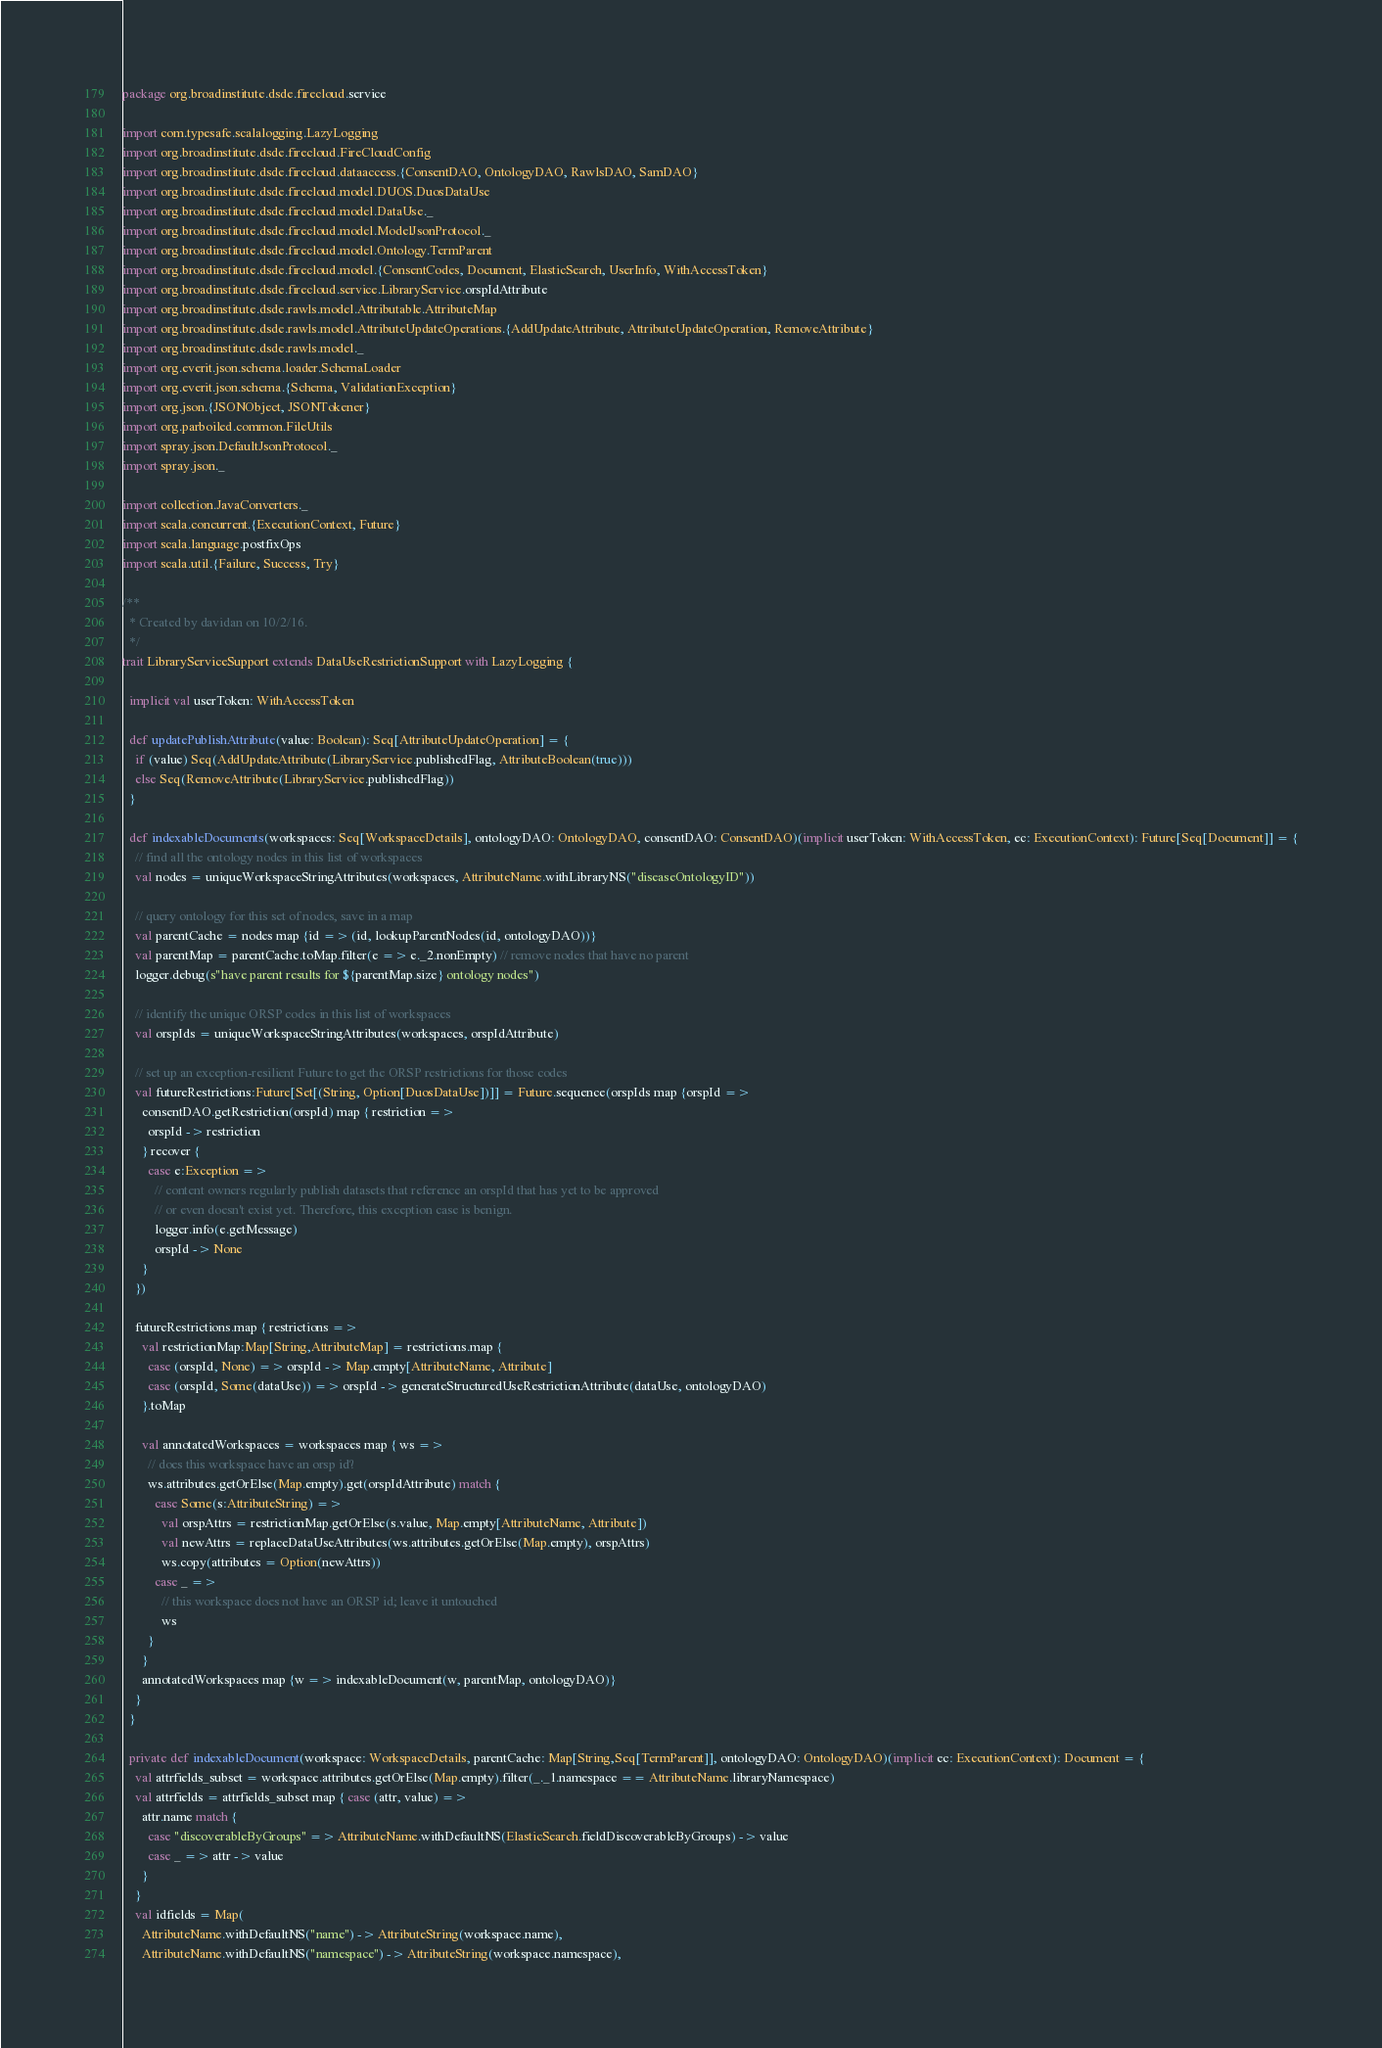<code> <loc_0><loc_0><loc_500><loc_500><_Scala_>package org.broadinstitute.dsde.firecloud.service

import com.typesafe.scalalogging.LazyLogging
import org.broadinstitute.dsde.firecloud.FireCloudConfig
import org.broadinstitute.dsde.firecloud.dataaccess.{ConsentDAO, OntologyDAO, RawlsDAO, SamDAO}
import org.broadinstitute.dsde.firecloud.model.DUOS.DuosDataUse
import org.broadinstitute.dsde.firecloud.model.DataUse._
import org.broadinstitute.dsde.firecloud.model.ModelJsonProtocol._
import org.broadinstitute.dsde.firecloud.model.Ontology.TermParent
import org.broadinstitute.dsde.firecloud.model.{ConsentCodes, Document, ElasticSearch, UserInfo, WithAccessToken}
import org.broadinstitute.dsde.firecloud.service.LibraryService.orspIdAttribute
import org.broadinstitute.dsde.rawls.model.Attributable.AttributeMap
import org.broadinstitute.dsde.rawls.model.AttributeUpdateOperations.{AddUpdateAttribute, AttributeUpdateOperation, RemoveAttribute}
import org.broadinstitute.dsde.rawls.model._
import org.everit.json.schema.loader.SchemaLoader
import org.everit.json.schema.{Schema, ValidationException}
import org.json.{JSONObject, JSONTokener}
import org.parboiled.common.FileUtils
import spray.json.DefaultJsonProtocol._
import spray.json._

import collection.JavaConverters._
import scala.concurrent.{ExecutionContext, Future}
import scala.language.postfixOps
import scala.util.{Failure, Success, Try}

/**
  * Created by davidan on 10/2/16.
  */
trait LibraryServiceSupport extends DataUseRestrictionSupport with LazyLogging {

  implicit val userToken: WithAccessToken

  def updatePublishAttribute(value: Boolean): Seq[AttributeUpdateOperation] = {
    if (value) Seq(AddUpdateAttribute(LibraryService.publishedFlag, AttributeBoolean(true)))
    else Seq(RemoveAttribute(LibraryService.publishedFlag))
  }

  def indexableDocuments(workspaces: Seq[WorkspaceDetails], ontologyDAO: OntologyDAO, consentDAO: ConsentDAO)(implicit userToken: WithAccessToken, ec: ExecutionContext): Future[Seq[Document]] = {
    // find all the ontology nodes in this list of workspaces
    val nodes = uniqueWorkspaceStringAttributes(workspaces, AttributeName.withLibraryNS("diseaseOntologyID"))

    // query ontology for this set of nodes, save in a map
    val parentCache = nodes map {id => (id, lookupParentNodes(id, ontologyDAO))}
    val parentMap = parentCache.toMap.filter(e => e._2.nonEmpty) // remove nodes that have no parent
    logger.debug(s"have parent results for ${parentMap.size} ontology nodes")

    // identify the unique ORSP codes in this list of workspaces
    val orspIds = uniqueWorkspaceStringAttributes(workspaces, orspIdAttribute)

    // set up an exception-resilient Future to get the ORSP restrictions for those codes
    val futureRestrictions:Future[Set[(String, Option[DuosDataUse])]] = Future.sequence(orspIds map {orspId =>
      consentDAO.getRestriction(orspId) map { restriction =>
        orspId -> restriction
      } recover {
        case e:Exception =>
          // content owners regularly publish datasets that reference an orspId that has yet to be approved
          // or even doesn't exist yet. Therefore, this exception case is benign.
          logger.info(e.getMessage)
          orspId -> None
      }
    })

    futureRestrictions.map { restrictions =>
      val restrictionMap:Map[String,AttributeMap] = restrictions.map {
        case (orspId, None) => orspId -> Map.empty[AttributeName, Attribute]
        case (orspId, Some(dataUse)) => orspId -> generateStructuredUseRestrictionAttribute(dataUse, ontologyDAO)
      }.toMap

      val annotatedWorkspaces = workspaces map { ws =>
        // does this workspace have an orsp id?
        ws.attributes.getOrElse(Map.empty).get(orspIdAttribute) match {
          case Some(s:AttributeString) =>
            val orspAttrs = restrictionMap.getOrElse(s.value, Map.empty[AttributeName, Attribute])
            val newAttrs = replaceDataUseAttributes(ws.attributes.getOrElse(Map.empty), orspAttrs)
            ws.copy(attributes = Option(newAttrs))
          case _ =>
            // this workspace does not have an ORSP id; leave it untouched
            ws
        }
      }
      annotatedWorkspaces map {w => indexableDocument(w, parentMap, ontologyDAO)}
    }
  }

  private def indexableDocument(workspace: WorkspaceDetails, parentCache: Map[String,Seq[TermParent]], ontologyDAO: OntologyDAO)(implicit ec: ExecutionContext): Document = {
    val attrfields_subset = workspace.attributes.getOrElse(Map.empty).filter(_._1.namespace == AttributeName.libraryNamespace)
    val attrfields = attrfields_subset map { case (attr, value) =>
      attr.name match {
        case "discoverableByGroups" => AttributeName.withDefaultNS(ElasticSearch.fieldDiscoverableByGroups) -> value
        case _ => attr -> value
      }
    }
    val idfields = Map(
      AttributeName.withDefaultNS("name") -> AttributeString(workspace.name),
      AttributeName.withDefaultNS("namespace") -> AttributeString(workspace.namespace),</code> 